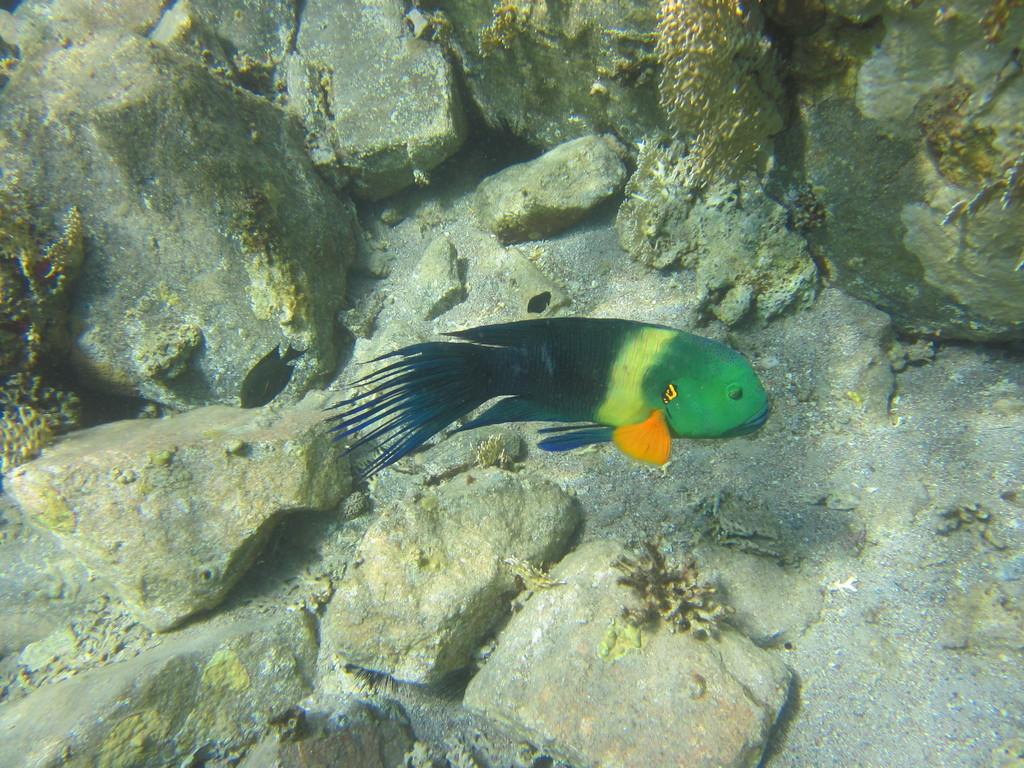What type of animal can be seen in the image? There is a fish in the image. What is the primary element surrounding the fish? There is water in the image. What other objects or features are present in the water? There are rocks and algae in the image. What type of pancake can be seen floating in the water in the image? There is no pancake present in the image; it features a fish in water with rocks and algae. 